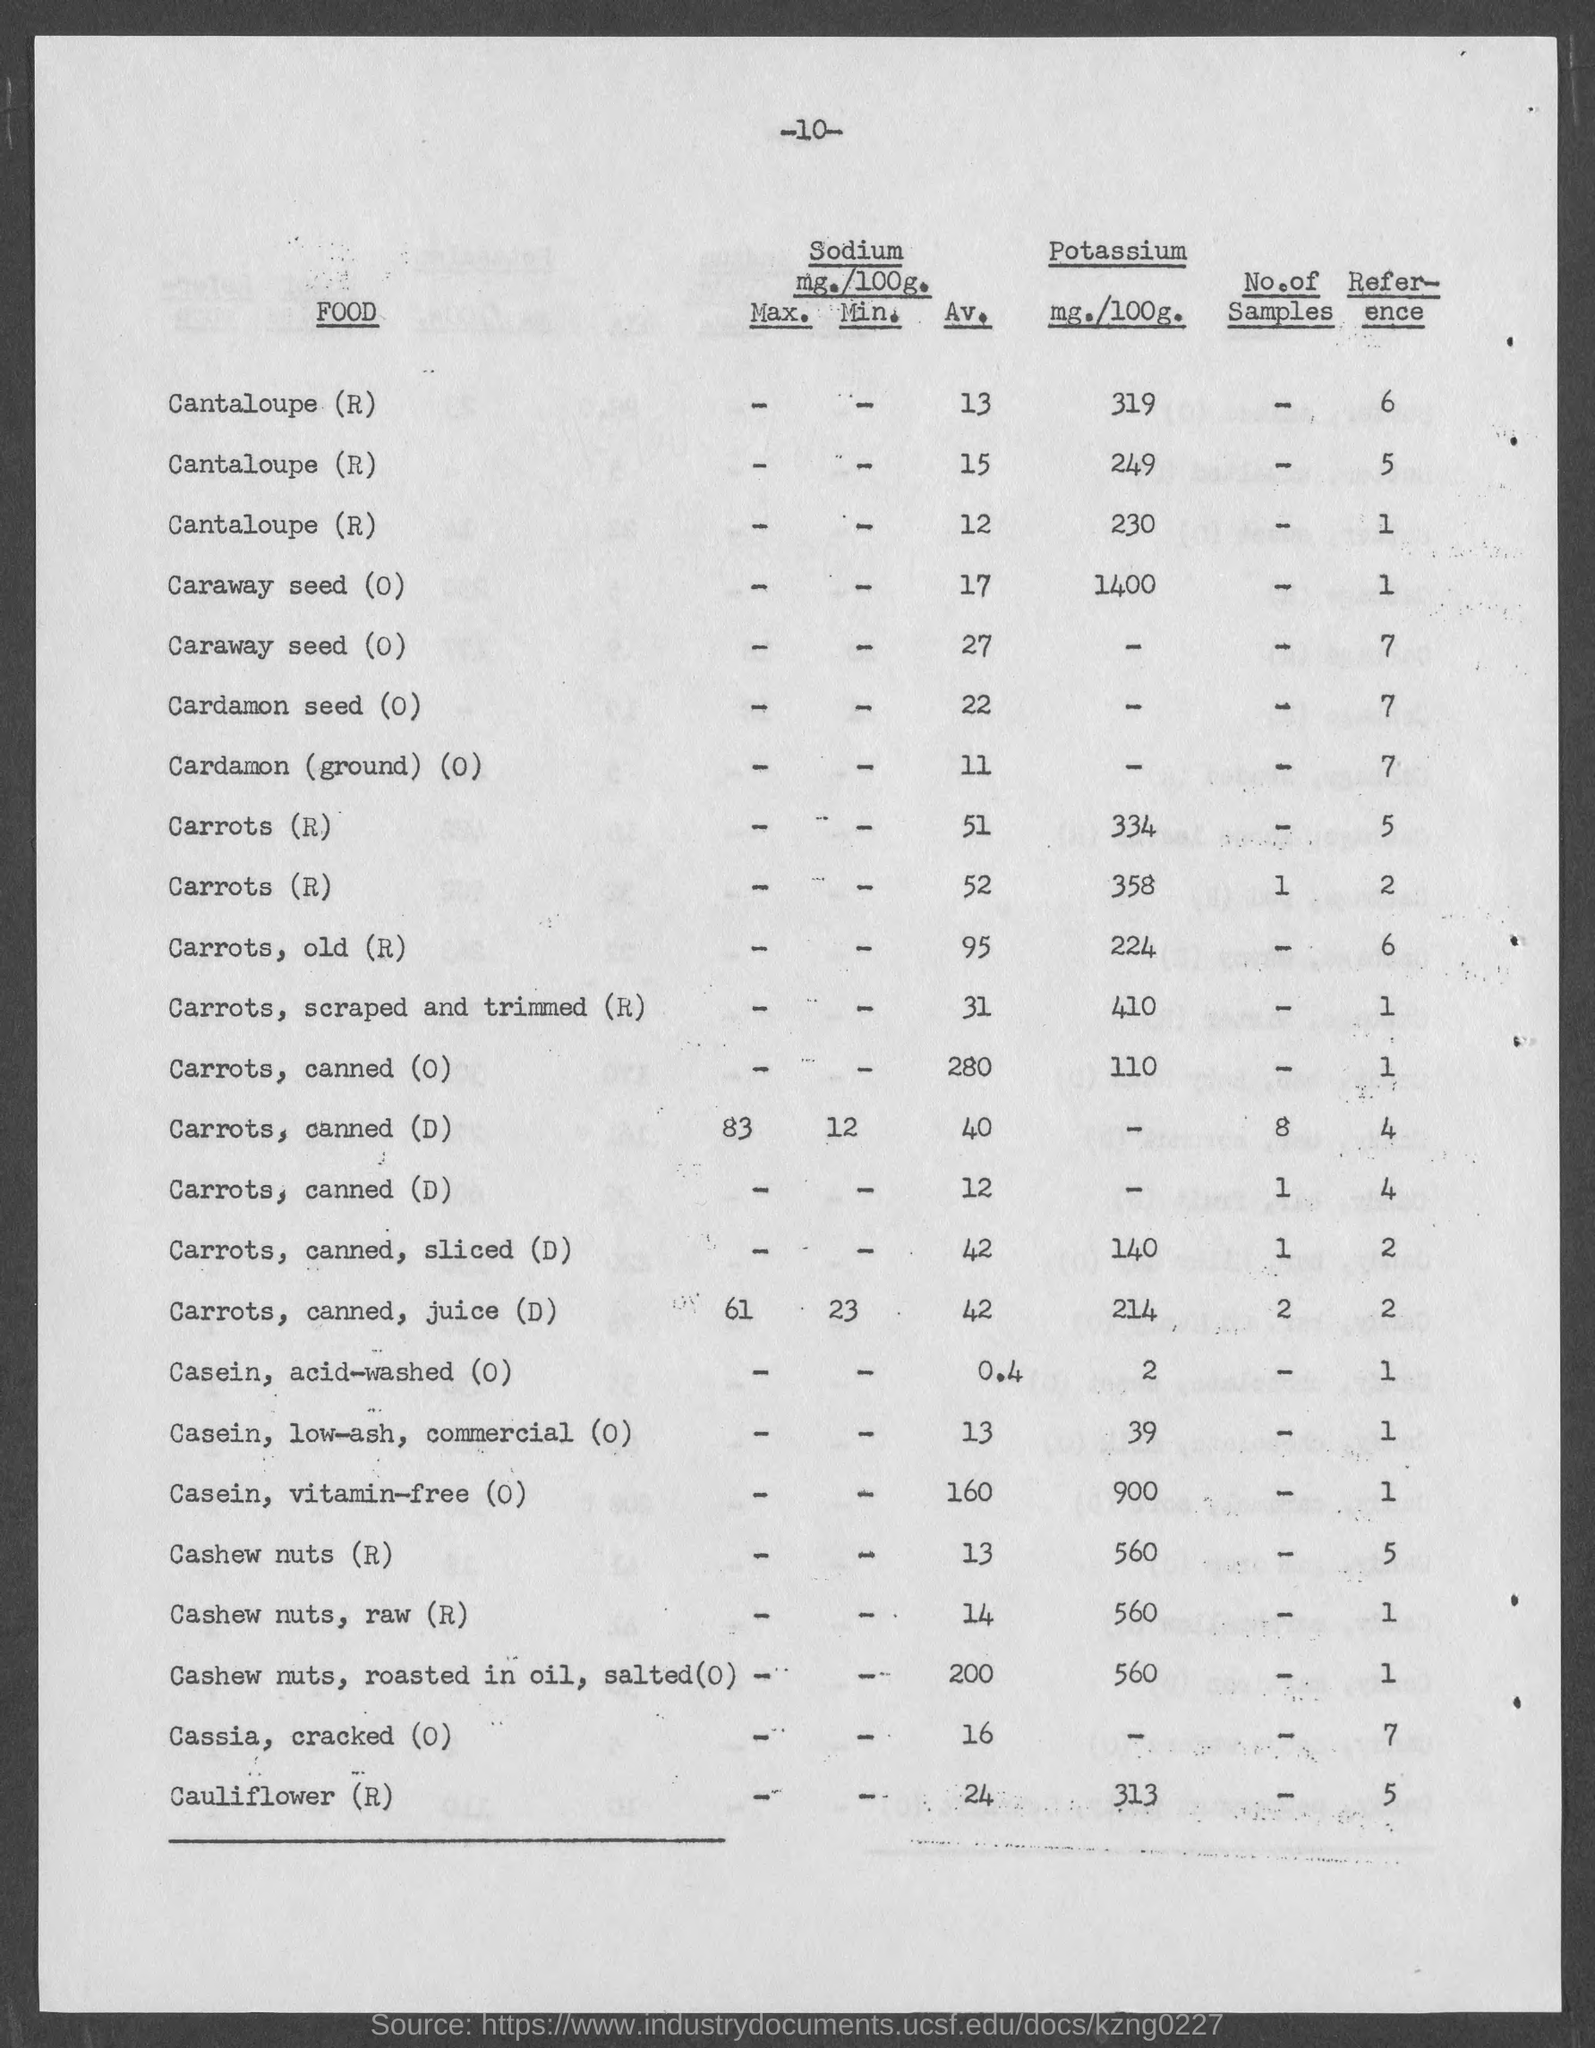Point out several critical features in this image. The raw cashew nuts contain 560 milligrams of potassium per 100 grams of the substance. The amount of potassium in 100 grams of Casein, low-ash, commercial (O) is 39 milligrams. The amount of potassium in cauliflower (R) is 313 milligrams per 100 grams. The amount of potassium in cashew nuts (R) is 560 mg per 100 g. The amount of potassium in cashew nuts, roasted in oil and salted (O), is 560 milligrams per 100 grams. 